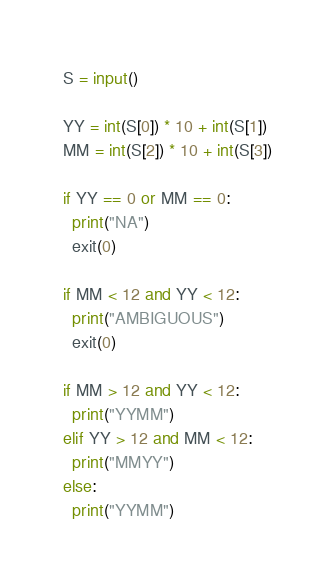<code> <loc_0><loc_0><loc_500><loc_500><_Python_>S = input()

YY = int(S[0]) * 10 + int(S[1])
MM = int(S[2]) * 10 + int(S[3])

if YY == 0 or MM == 0:
  print("NA")
  exit(0)

if MM < 12 and YY < 12:
  print("AMBIGUOUS")
  exit(0)
  
if MM > 12 and YY < 12:
  print("YYMM")
elif YY > 12 and MM < 12:
  print("MMYY")
else:
  print("YYMM")</code> 